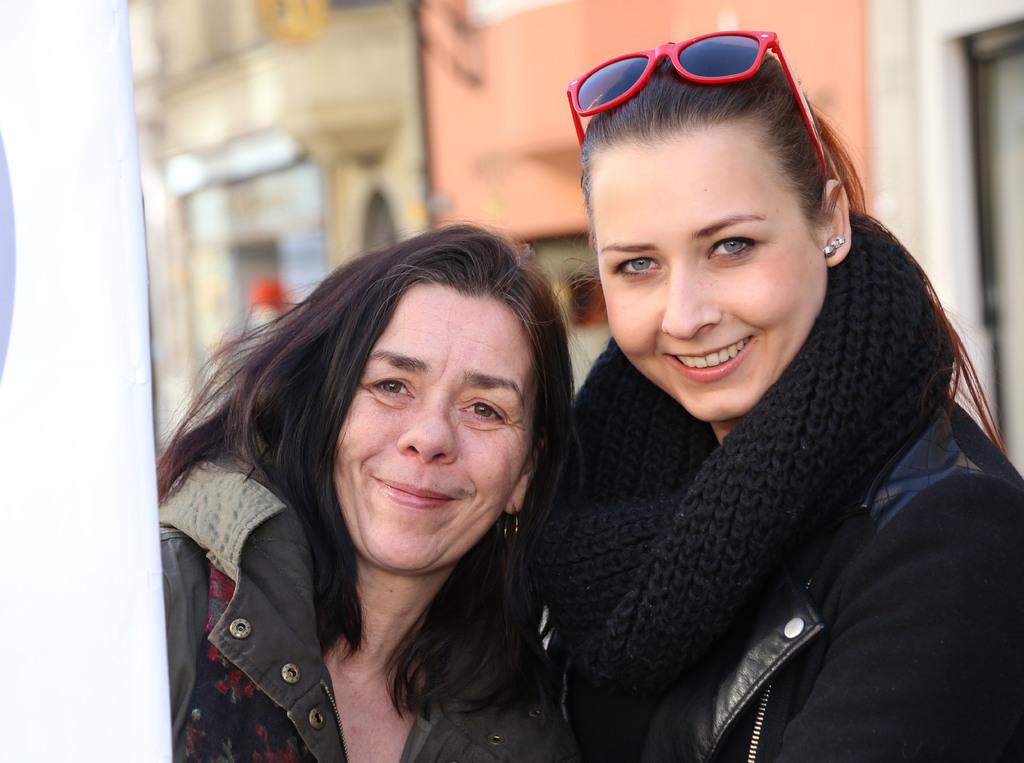How many women are present in the image? There are two women in the image. What is the facial expression of the women? Both women are smiling. What can be seen in the background of the image? There is a building in the background of the image. How would you describe the background's appearance? The background of the image appears blurry. What is one woman wearing in the image? One woman on the right side is wearing a scarf. What type of toy can be seen on the island in the image? There is no toy or island present in the image. What flavor of jam is being spread on the bread in the image? There is no bread or jam present in the image. 